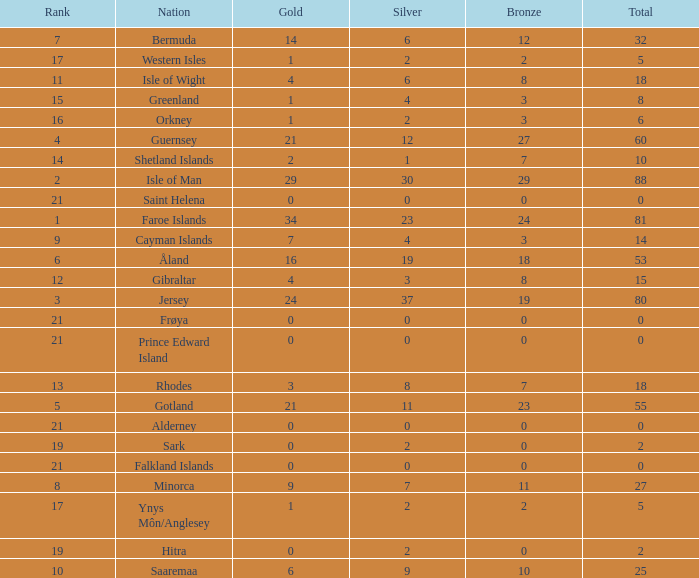Could you help me parse every detail presented in this table? {'header': ['Rank', 'Nation', 'Gold', 'Silver', 'Bronze', 'Total'], 'rows': [['7', 'Bermuda', '14', '6', '12', '32'], ['17', 'Western Isles', '1', '2', '2', '5'], ['11', 'Isle of Wight', '4', '6', '8', '18'], ['15', 'Greenland', '1', '4', '3', '8'], ['16', 'Orkney', '1', '2', '3', '6'], ['4', 'Guernsey', '21', '12', '27', '60'], ['14', 'Shetland Islands', '2', '1', '7', '10'], ['2', 'Isle of Man', '29', '30', '29', '88'], ['21', 'Saint Helena', '0', '0', '0', '0'], ['1', 'Faroe Islands', '34', '23', '24', '81'], ['9', 'Cayman Islands', '7', '4', '3', '14'], ['6', 'Åland', '16', '19', '18', '53'], ['12', 'Gibraltar', '4', '3', '8', '15'], ['3', 'Jersey', '24', '37', '19', '80'], ['21', 'Frøya', '0', '0', '0', '0'], ['21', 'Prince Edward Island', '0', '0', '0', '0'], ['13', 'Rhodes', '3', '8', '7', '18'], ['5', 'Gotland', '21', '11', '23', '55'], ['21', 'Alderney', '0', '0', '0', '0'], ['19', 'Sark', '0', '2', '0', '2'], ['21', 'Falkland Islands', '0', '0', '0', '0'], ['8', 'Minorca', '9', '7', '11', '27'], ['17', 'Ynys Môn/Anglesey', '1', '2', '2', '5'], ['19', 'Hitra', '0', '2', '0', '2'], ['10', 'Saaremaa', '6', '9', '10', '25']]} How many Silver medals were won in total by all those with more than 3 bronze and exactly 16 gold? 19.0. 